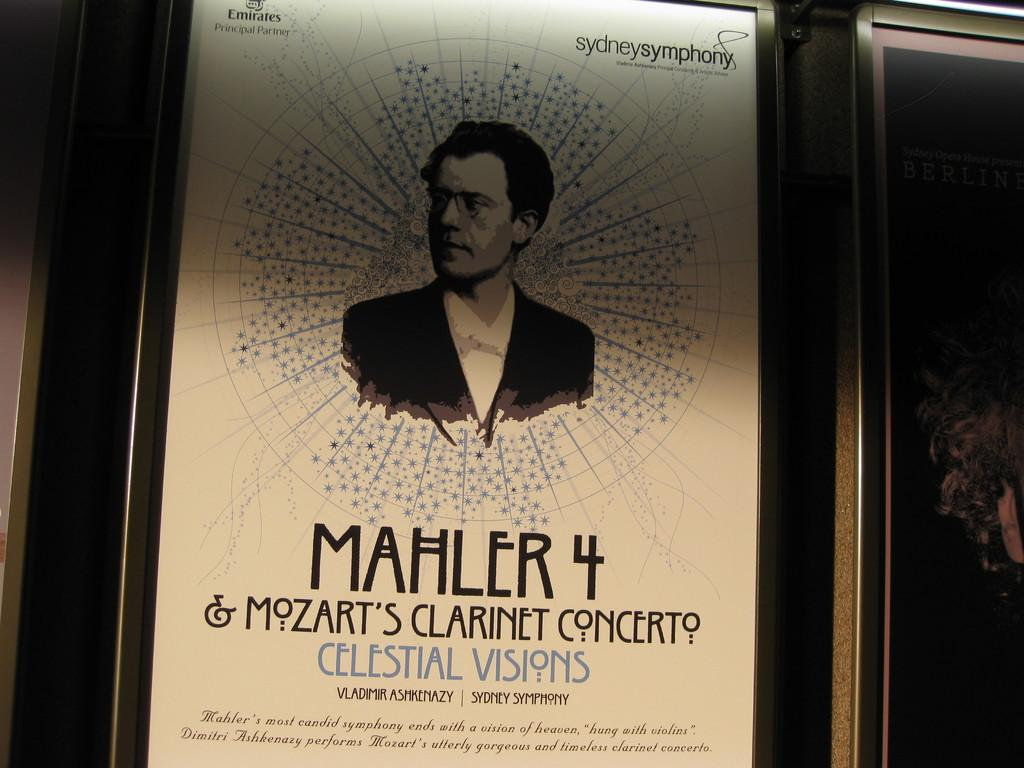<image>
Write a terse but informative summary of the picture. An old poster for Sydney Symphony Mahler 4 